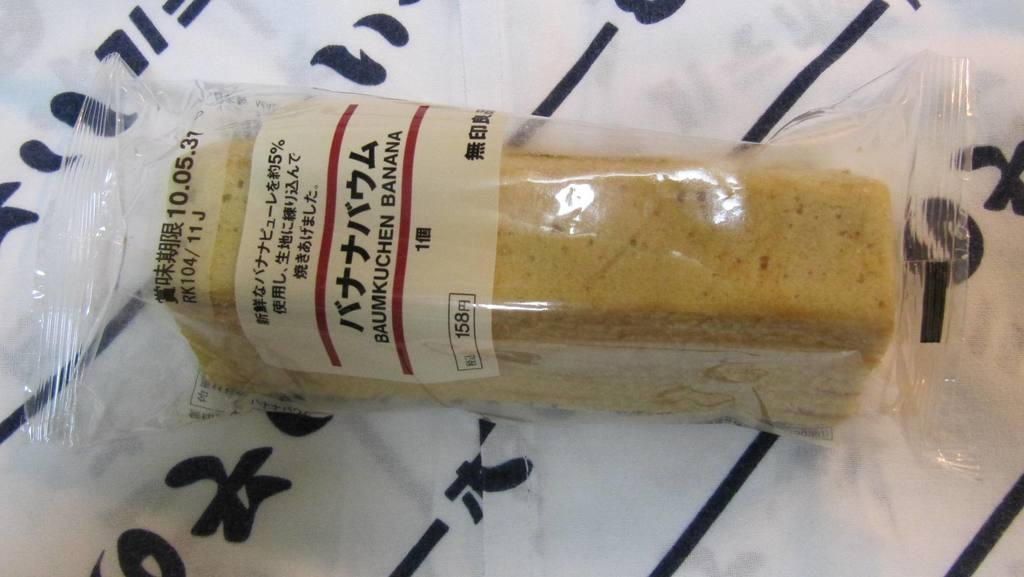<image>
Present a compact description of the photo's key features. A loaf of Baumkuchen Banana bread in clear cellophane lying on white piece of paper with black lettering. 